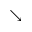Convert formula to latex. <formula><loc_0><loc_0><loc_500><loc_500>\searrow</formula> 